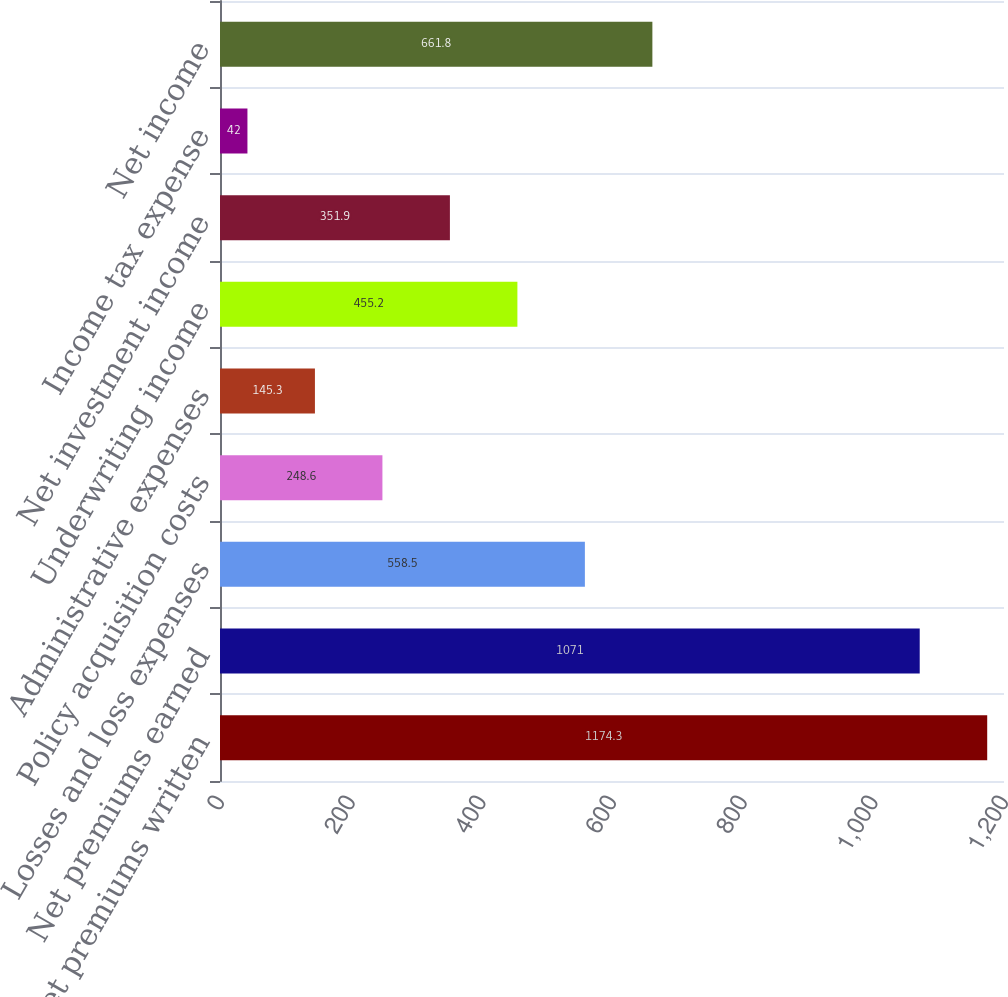Convert chart. <chart><loc_0><loc_0><loc_500><loc_500><bar_chart><fcel>Net premiums written<fcel>Net premiums earned<fcel>Losses and loss expenses<fcel>Policy acquisition costs<fcel>Administrative expenses<fcel>Underwriting income<fcel>Net investment income<fcel>Income tax expense<fcel>Net income<nl><fcel>1174.3<fcel>1071<fcel>558.5<fcel>248.6<fcel>145.3<fcel>455.2<fcel>351.9<fcel>42<fcel>661.8<nl></chart> 